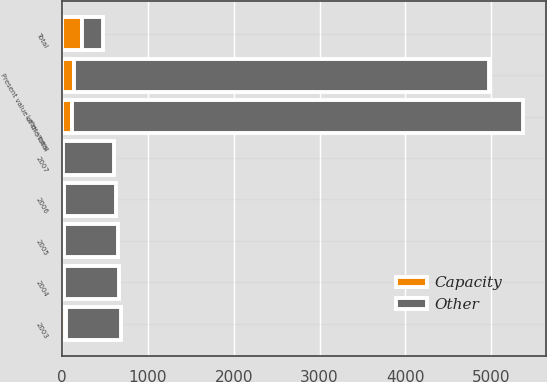Convert chart to OTSL. <chart><loc_0><loc_0><loc_500><loc_500><stacked_bar_chart><ecel><fcel>2003<fcel>2004<fcel>2005<fcel>2006<fcel>2007<fcel>Later years<fcel>Total<fcel>Present value of the total<nl><fcel>Other<fcel>643<fcel>635<fcel>629<fcel>614<fcel>589<fcel>5259<fcel>237<fcel>4836<nl><fcel>Capacity<fcel>44<fcel>29<fcel>22<fcel>18<fcel>11<fcel>113<fcel>237<fcel>140<nl></chart> 